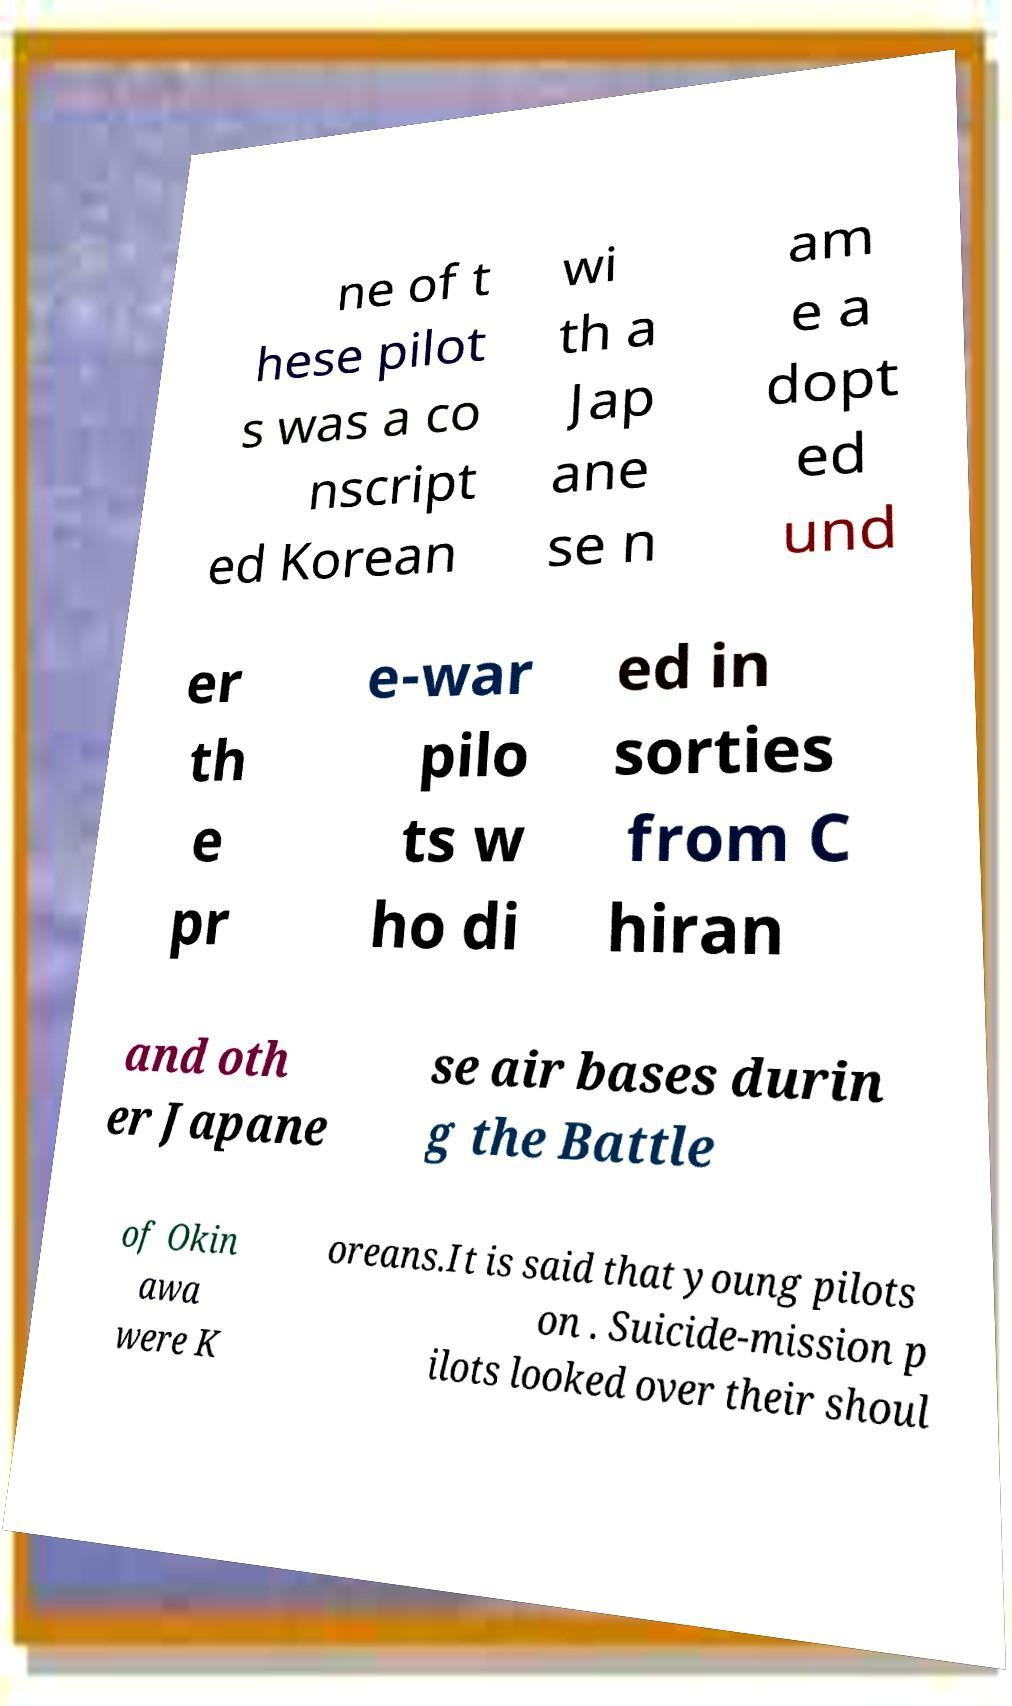Can you accurately transcribe the text from the provided image for me? ne of t hese pilot s was a co nscript ed Korean wi th a Jap ane se n am e a dopt ed und er th e pr e-war pilo ts w ho di ed in sorties from C hiran and oth er Japane se air bases durin g the Battle of Okin awa were K oreans.It is said that young pilots on . Suicide-mission p ilots looked over their shoul 